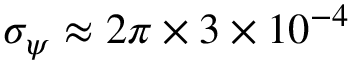Convert formula to latex. <formula><loc_0><loc_0><loc_500><loc_500>\sigma _ { \psi } \approx 2 \pi \times 3 \times 1 0 ^ { - 4 }</formula> 